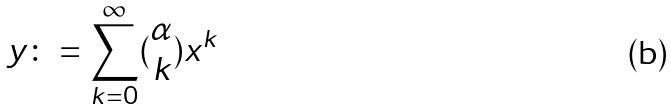<formula> <loc_0><loc_0><loc_500><loc_500>y \colon = \sum _ { k = 0 } ^ { \infty } ( \begin{matrix} \alpha \\ k \end{matrix} ) x ^ { k }</formula> 